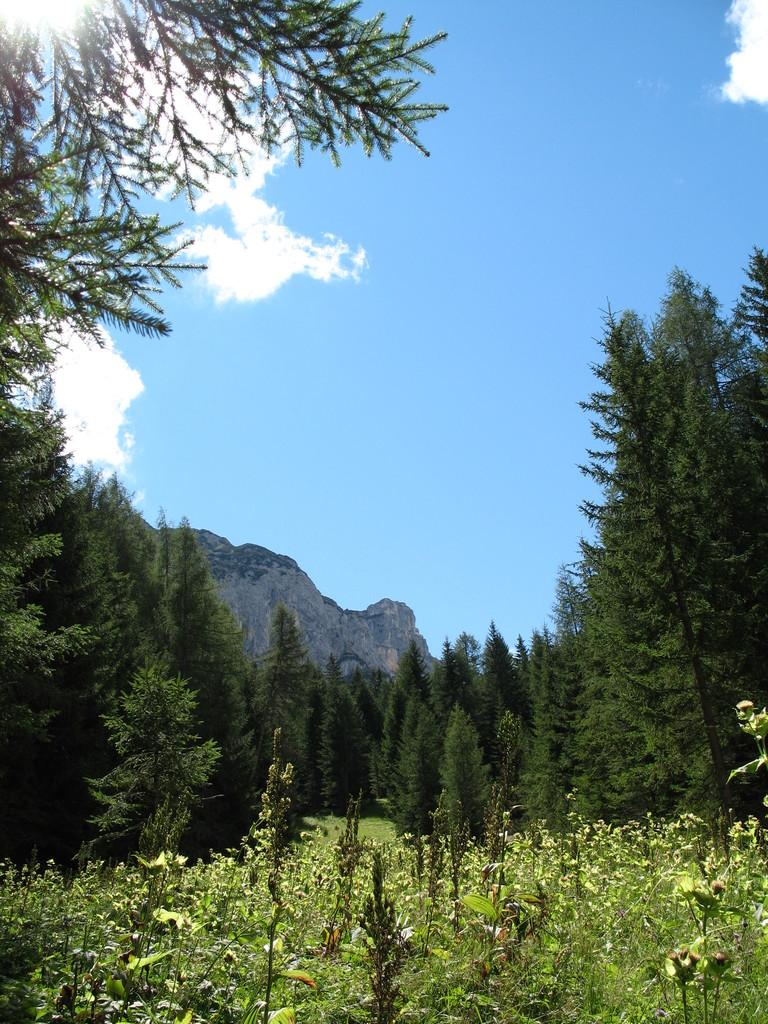What type of surface is visible in the image? There is grass on the surface in the image. What can be seen in the background of the image? There are trees and mountains in the background of the image. What is visible in the sky in the image? The sky is visible in the background of the image. What is the tendency of the coast in the image? There is no coast present in the image; it features grass, trees, mountains, and the sky. 